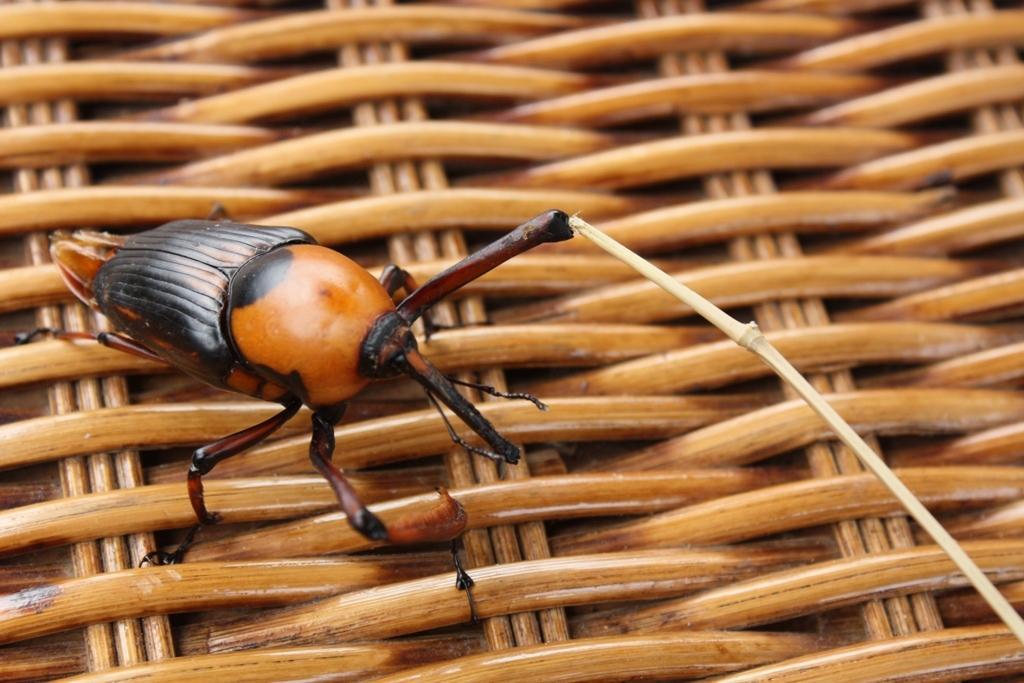Can you describe this image briefly? In this picture there is an insect, on a wooden object. 